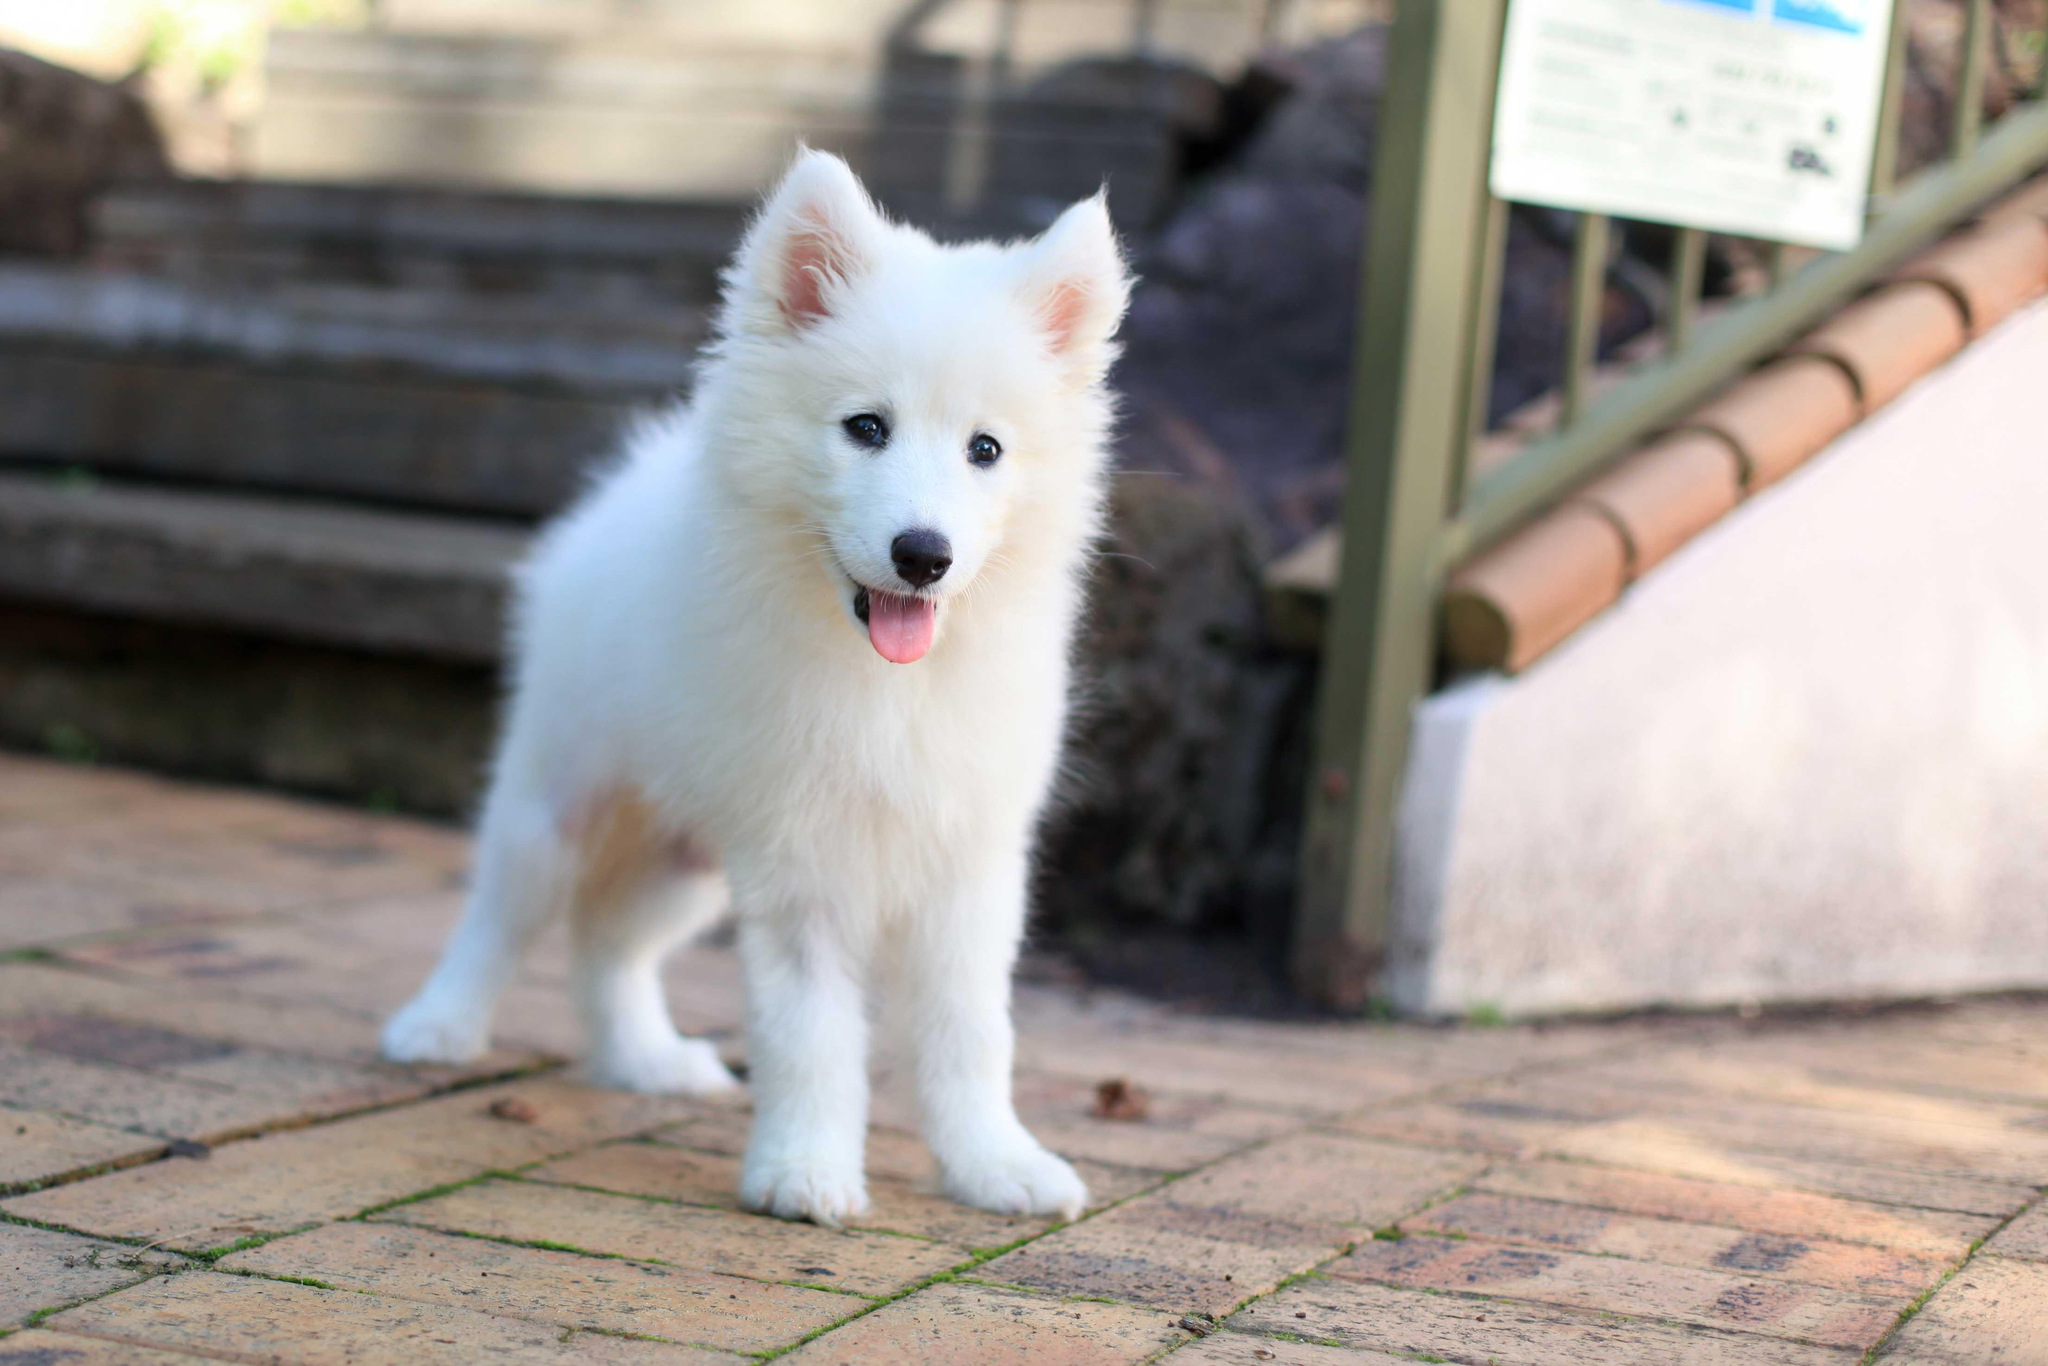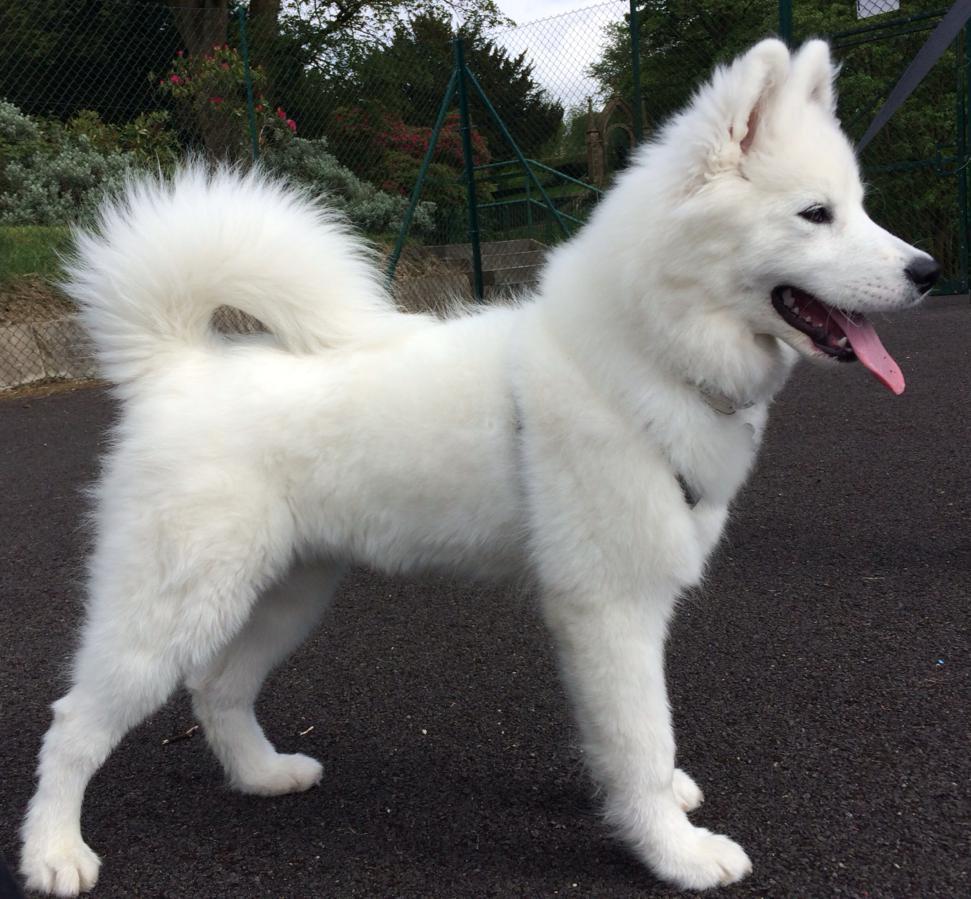The first image is the image on the left, the second image is the image on the right. For the images shown, is this caption "A dog is looking toward the right side." true? Answer yes or no. Yes. The first image is the image on the left, the second image is the image on the right. For the images shown, is this caption "One image shows exactly one white dog with its ears flopped forward, and the other image shows one dog with 'salt-and-pepper' fur coloring, and all dogs shown are young instead of full grown." true? Answer yes or no. No. 